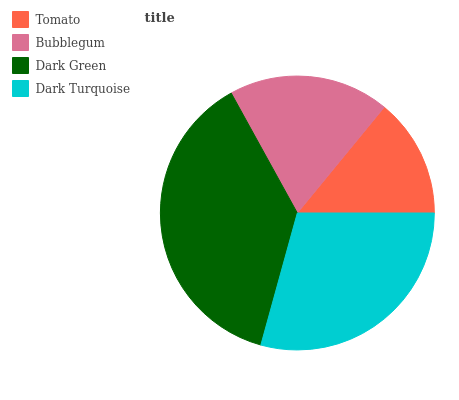Is Tomato the minimum?
Answer yes or no. Yes. Is Dark Green the maximum?
Answer yes or no. Yes. Is Bubblegum the minimum?
Answer yes or no. No. Is Bubblegum the maximum?
Answer yes or no. No. Is Bubblegum greater than Tomato?
Answer yes or no. Yes. Is Tomato less than Bubblegum?
Answer yes or no. Yes. Is Tomato greater than Bubblegum?
Answer yes or no. No. Is Bubblegum less than Tomato?
Answer yes or no. No. Is Dark Turquoise the high median?
Answer yes or no. Yes. Is Bubblegum the low median?
Answer yes or no. Yes. Is Tomato the high median?
Answer yes or no. No. Is Tomato the low median?
Answer yes or no. No. 